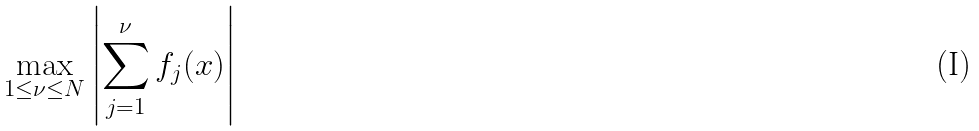Convert formula to latex. <formula><loc_0><loc_0><loc_500><loc_500>\max _ { 1 \leq \nu \leq N } \left | \sum _ { j = 1 } ^ { \nu } f _ { j } ( x ) \right |</formula> 